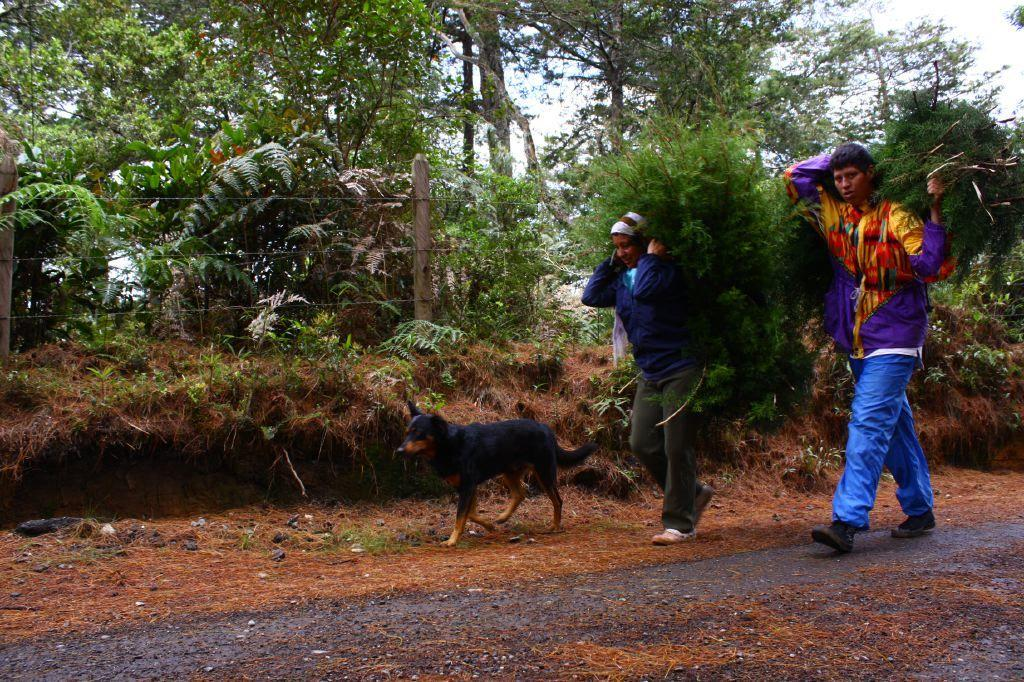How many people are in the image? There are two persons in the image. What are the persons doing in the image? The persons are carrying branches of trees. What animal can be seen on the ground in the image? There is a dog on the ground in the image. What type of barrier is present in the image? There is a fence in the image. What other object made of wood can be seen in the image? There is a wooden pole in the image. What type of vegetation is visible in the image? There are trees in the image. What part of the natural environment is visible in the background of the image? The sky is visible in the background of the image. How does the fog affect the visibility of the wooden pole in the image? There is no fog present in the image, so its effect on the visibility of the wooden pole cannot be determined. 